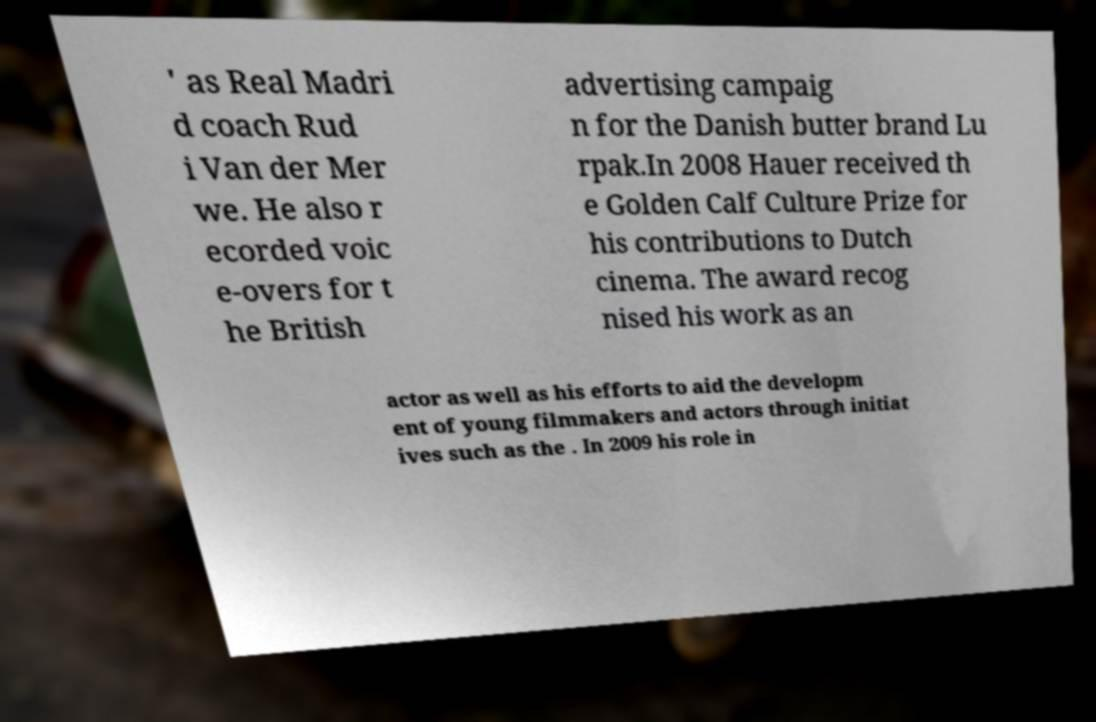Can you accurately transcribe the text from the provided image for me? ' as Real Madri d coach Rud i Van der Mer we. He also r ecorded voic e-overs for t he British advertising campaig n for the Danish butter brand Lu rpak.In 2008 Hauer received th e Golden Calf Culture Prize for his contributions to Dutch cinema. The award recog nised his work as an actor as well as his efforts to aid the developm ent of young filmmakers and actors through initiat ives such as the . In 2009 his role in 